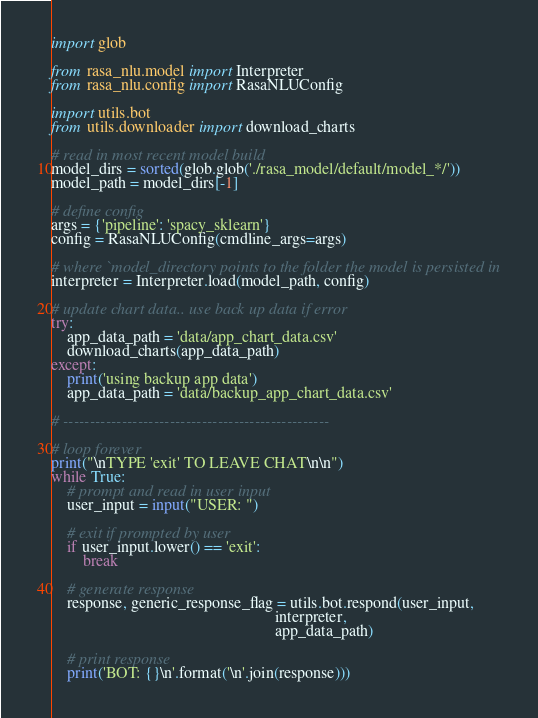<code> <loc_0><loc_0><loc_500><loc_500><_Python_>import glob

from rasa_nlu.model import Interpreter
from rasa_nlu.config import RasaNLUConfig

import utils.bot
from utils.downloader import download_charts

# read in most recent model build
model_dirs = sorted(glob.glob('./rasa_model/default/model_*/'))
model_path = model_dirs[-1]

# define config
args = {'pipeline': 'spacy_sklearn'}
config = RasaNLUConfig(cmdline_args=args)

# where `model_directory points to the folder the model is persisted in
interpreter = Interpreter.load(model_path, config)

# update chart data.. use back up data if error
try:
    app_data_path = 'data/app_chart_data.csv'
    download_charts(app_data_path)
except:
    print('using backup app data')
    app_data_path = 'data/backup_app_chart_data.csv'

# --------------------------------------------------

# loop forever
print("\nTYPE 'exit' TO LEAVE CHAT\n\n")
while True:
    # prompt and read in user input
    user_input = input("USER: ")

    # exit if prompted by user
    if user_input.lower() == 'exit':
        break

    # generate response
    response, generic_response_flag = utils.bot.respond(user_input,
                                                        interpreter,
                                                        app_data_path)

    # print response
    print('BOT: {}\n'.format('\n'.join(response)))
</code> 